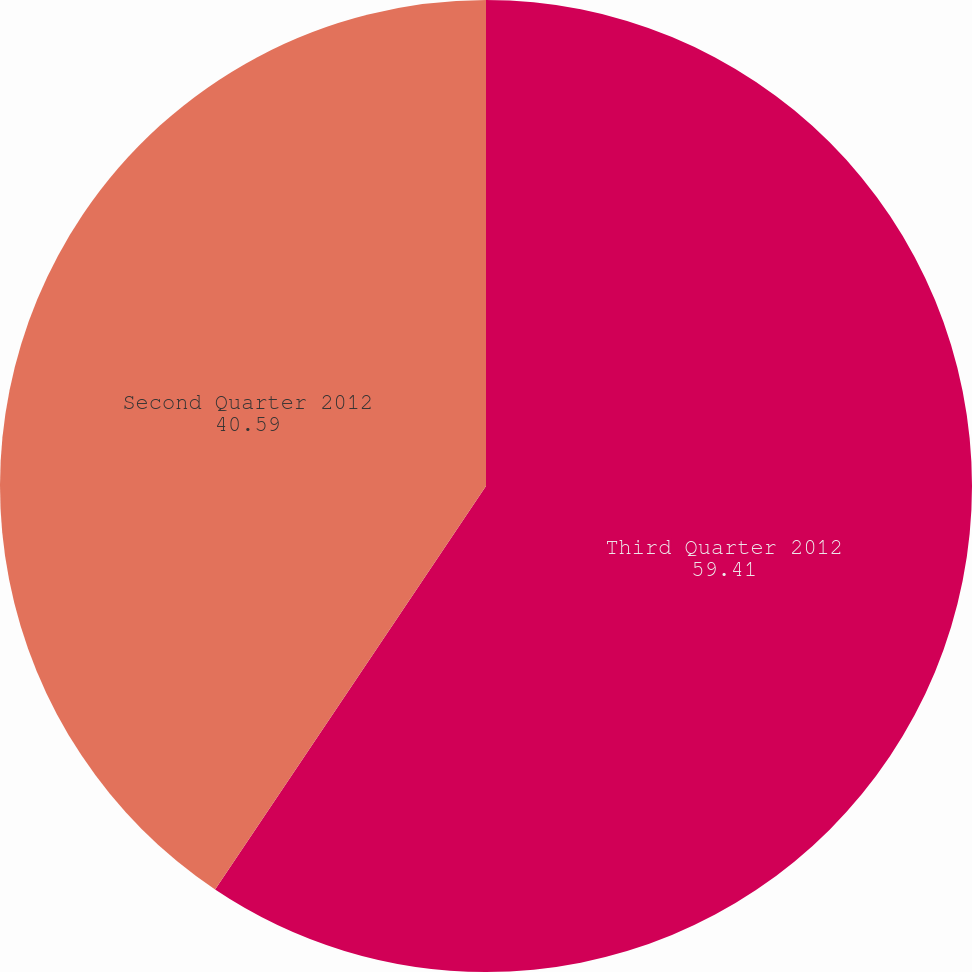Convert chart. <chart><loc_0><loc_0><loc_500><loc_500><pie_chart><fcel>Third Quarter 2012<fcel>Second Quarter 2012<nl><fcel>59.41%<fcel>40.59%<nl></chart> 